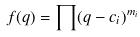<formula> <loc_0><loc_0><loc_500><loc_500>f ( q ) = \prod ( q - c _ { i } ) ^ { m _ { i } }</formula> 